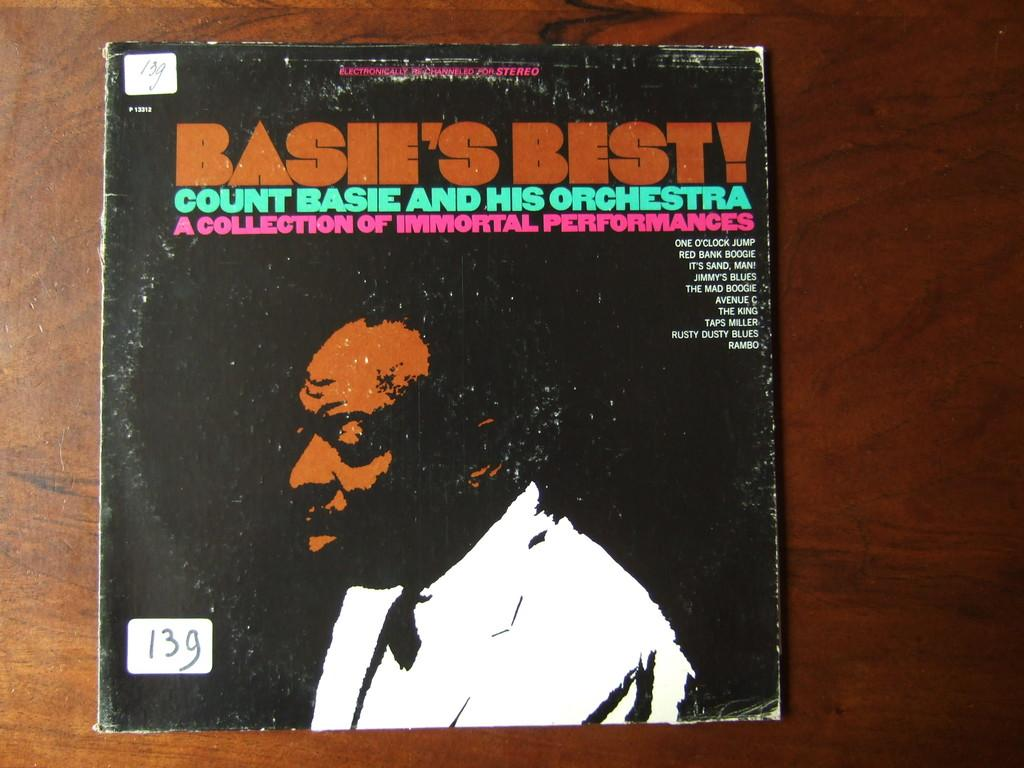<image>
Write a terse but informative summary of the picture. A record cover is marked 13g in the lower corner. 